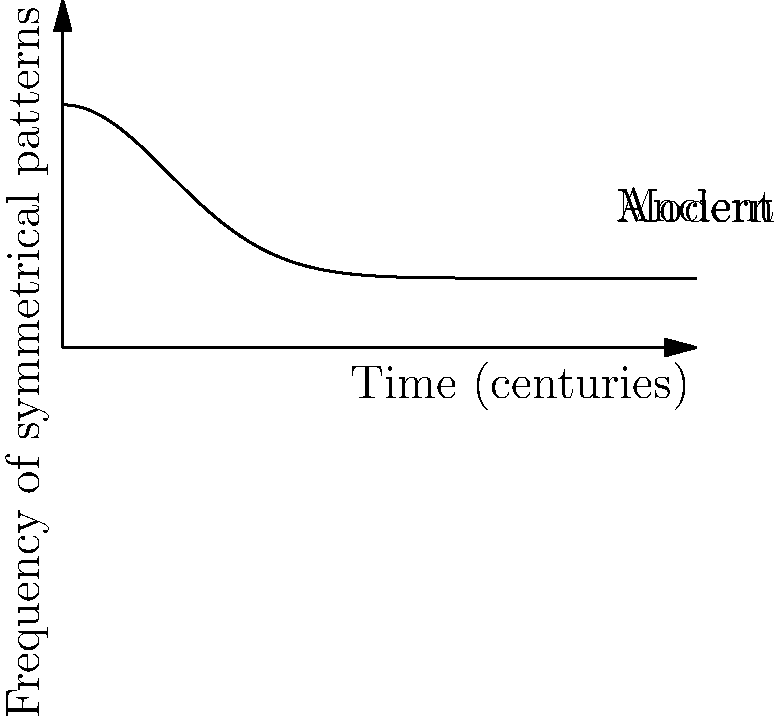The curve above represents the frequency of symmetrical patterns in art across different time periods, from ancient to modern times. If the area under this curve from 0 to 4 centuries represents the total prevalence of symmetrical patterns during that time span, calculate this area using calculus methods. Express your answer to two decimal places. To find the area under the curve, we need to integrate the function from 0 to 4. The steps are as follows:

1) The function appears to be of the form $f(x) = ae^{-bx^2} + c$, where $a=5$, $b=0.5$, and $c=2$.

2) We need to calculate $\int_0^4 (5e^{-0.5x^2} + 2) dx$

3) Let's break this into two parts:
   $\int_0^4 5e^{-0.5x^2} dx + \int_0^4 2 dx$

4) The second part is simple: $\int_0^4 2 dx = 2x|_0^4 = 8$

5) For the first part, we need to use the error function (erf):
   $\int e^{-ax^2} dx = \frac{\sqrt{\pi}}{2\sqrt{a}} \text{erf}(\sqrt{a}x)$

6) In our case, $a=0.5$, so:
   $5\int_0^4 e^{-0.5x^2} dx = 5 \cdot \frac{\sqrt{\pi}}{\sqrt{1}} [\text{erf}(\frac{x}{\sqrt{2}})]_0^4$
   $= 5\sqrt{\pi} [\text{erf}(\frac{4}{\sqrt{2}}) - \text{erf}(0)]$

7) $\text{erf}(0) = 0$ and $\text{erf}(\frac{4}{\sqrt{2}}) \approx 0.9993$

8) So, $5\sqrt{\pi} \cdot 0.9993 \approx 8.86$

9) Adding the results from steps 4 and 8:
   $8.86 + 8 = 16.86$
Answer: 16.86 